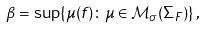Convert formula to latex. <formula><loc_0><loc_0><loc_500><loc_500>\beta = \sup \{ \mu ( f ) \colon \mu \in \mathcal { M } _ { \sigma } ( \Sigma _ { F } ) \} \, ,</formula> 